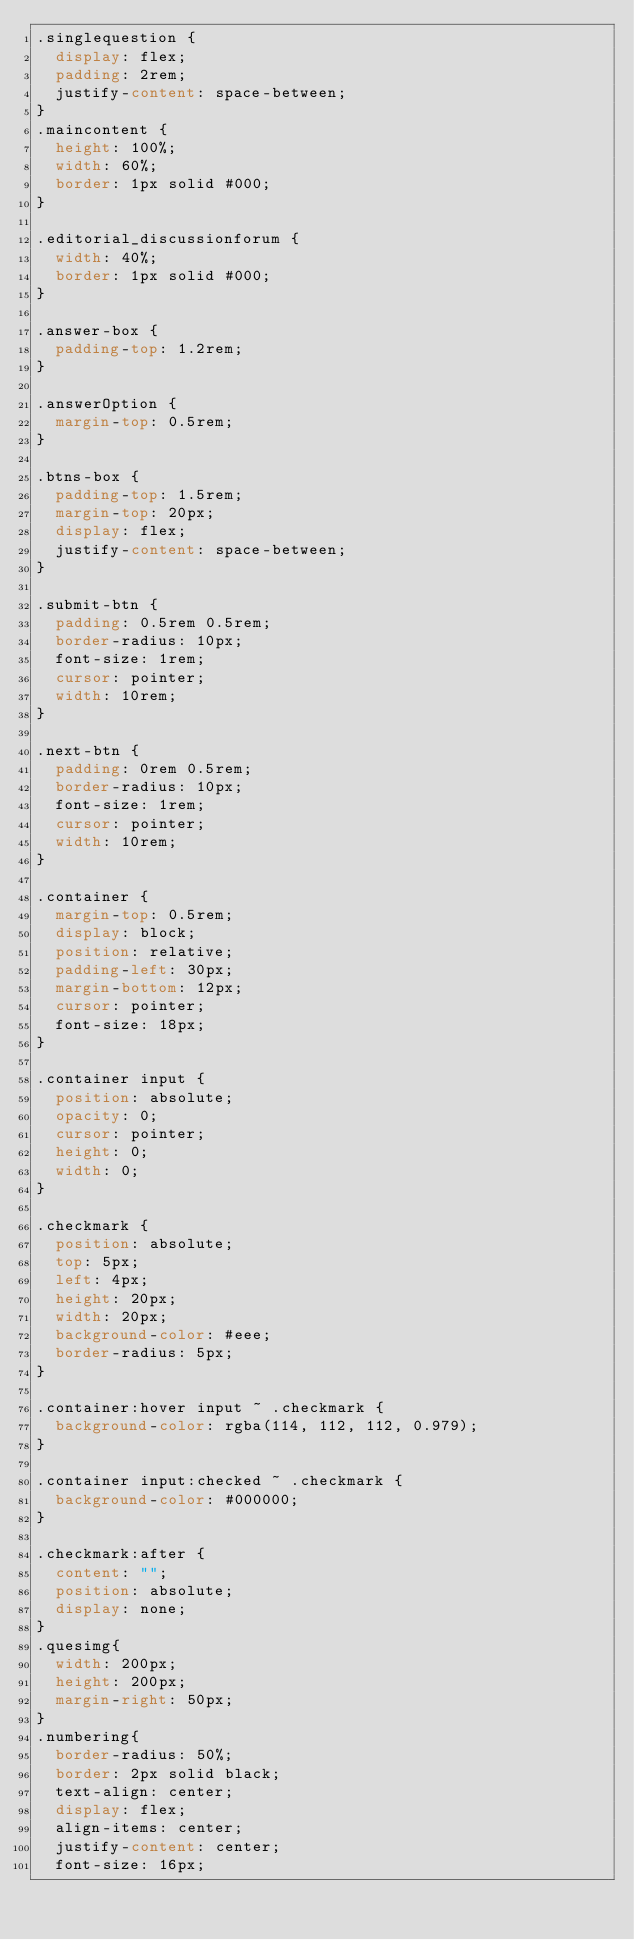Convert code to text. <code><loc_0><loc_0><loc_500><loc_500><_CSS_>.singlequestion {
  display: flex;
  padding: 2rem;
  justify-content: space-between;
}
.maincontent {
  height: 100%;
  width: 60%;
  border: 1px solid #000;
}

.editorial_discussionforum {
  width: 40%;
  border: 1px solid #000;
}

.answer-box {
  padding-top: 1.2rem;
}

.answerOption {
  margin-top: 0.5rem;
}

.btns-box {
  padding-top: 1.5rem;
  margin-top: 20px;
  display: flex;
  justify-content: space-between;
}

.submit-btn {
  padding: 0.5rem 0.5rem;
  border-radius: 10px;
  font-size: 1rem;
  cursor: pointer;
  width: 10rem;
}

.next-btn {
  padding: 0rem 0.5rem;
  border-radius: 10px;
  font-size: 1rem;
  cursor: pointer;
  width: 10rem;
}

.container {
  margin-top: 0.5rem;
  display: block;
  position: relative;
  padding-left: 30px;
  margin-bottom: 12px;
  cursor: pointer;
  font-size: 18px;
}

.container input {
  position: absolute;
  opacity: 0;
  cursor: pointer;
  height: 0;
  width: 0;
}

.checkmark {
  position: absolute;
  top: 5px;
  left: 4px;
  height: 20px;
  width: 20px;
  background-color: #eee;
  border-radius: 5px;
}

.container:hover input ~ .checkmark {
  background-color: rgba(114, 112, 112, 0.979);
}

.container input:checked ~ .checkmark {
  background-color: #000000;
}

.checkmark:after {
  content: "";
  position: absolute;
  display: none;
}
.quesimg{
  width: 200px;
  height: 200px;
  margin-right: 50px;
}
.numbering{
  border-radius: 50%;
  border: 2px solid black;
  text-align: center;
  display: flex;
  align-items: center;
  justify-content: center;
  font-size: 16px;</code> 